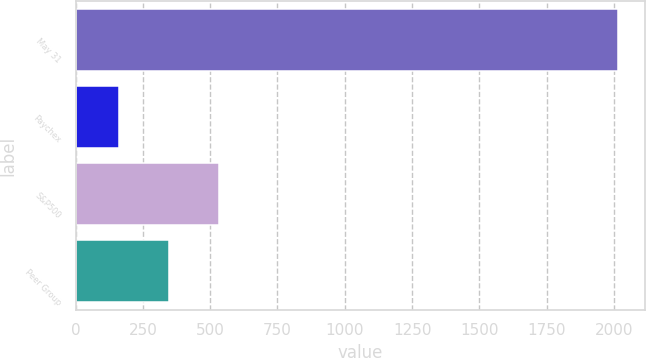Convert chart to OTSL. <chart><loc_0><loc_0><loc_500><loc_500><bar_chart><fcel>May 31<fcel>Paychex<fcel>S&P500<fcel>Peer Group<nl><fcel>2013<fcel>160.94<fcel>531.36<fcel>346.15<nl></chart> 